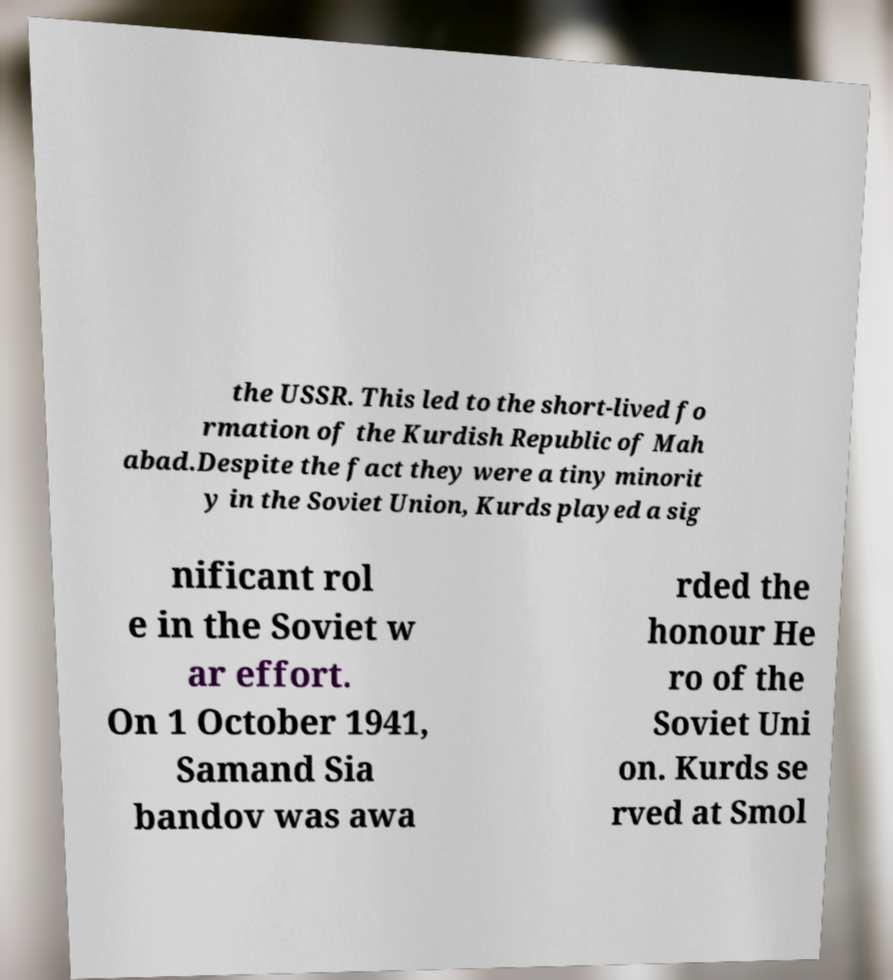What messages or text are displayed in this image? I need them in a readable, typed format. the USSR. This led to the short-lived fo rmation of the Kurdish Republic of Mah abad.Despite the fact they were a tiny minorit y in the Soviet Union, Kurds played a sig nificant rol e in the Soviet w ar effort. On 1 October 1941, Samand Sia bandov was awa rded the honour He ro of the Soviet Uni on. Kurds se rved at Smol 